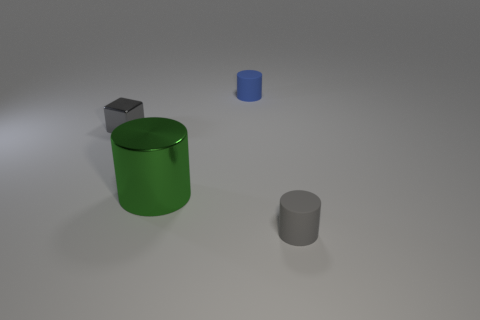What size is the rubber object that is behind the tiny cylinder in front of the gray object that is behind the large green cylinder?
Ensure brevity in your answer.  Small. Does the gray shiny object have the same size as the blue matte cylinder?
Ensure brevity in your answer.  Yes. Do the gray object on the right side of the metallic cube and the thing that is behind the tiny cube have the same shape?
Keep it short and to the point. Yes. There is a metallic object in front of the tiny cube; is there a matte object in front of it?
Give a very brief answer. Yes. Are there any small blocks?
Keep it short and to the point. Yes. What number of green objects are the same size as the green metallic cylinder?
Give a very brief answer. 0. How many things are both to the left of the blue cylinder and behind the green shiny thing?
Offer a terse response. 1. Does the matte object in front of the green metallic object have the same size as the blue cylinder?
Offer a very short reply. Yes. Are there any other rubber objects of the same color as the big object?
Give a very brief answer. No. The cube that is made of the same material as the big green object is what size?
Your answer should be compact. Small. 